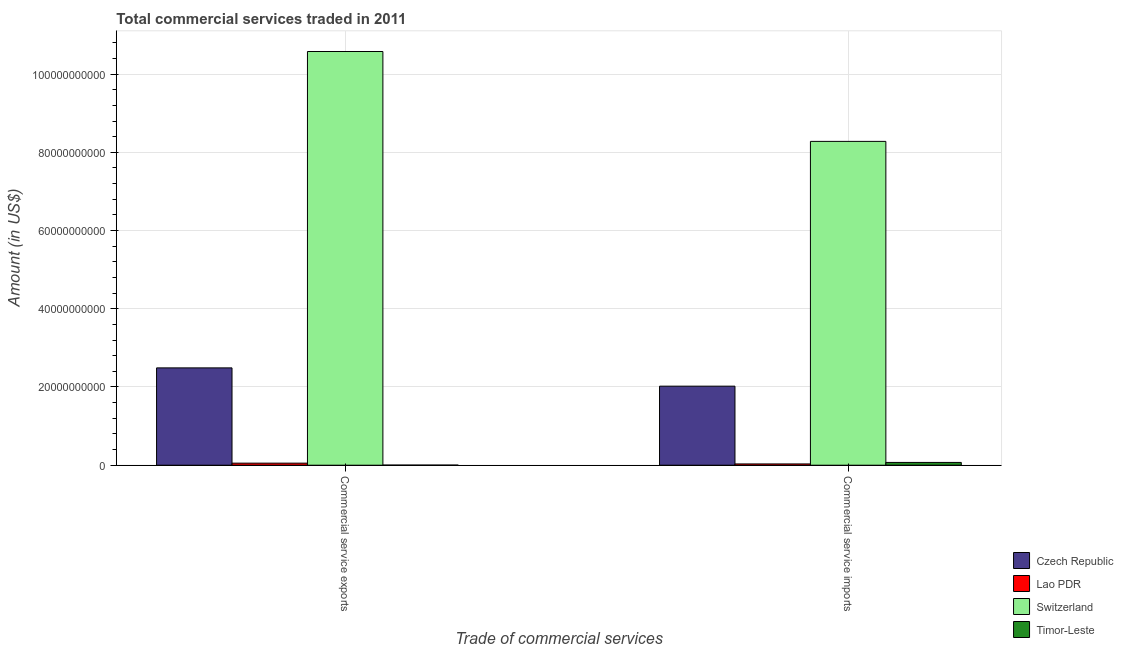How many different coloured bars are there?
Offer a terse response. 4. How many groups of bars are there?
Your answer should be compact. 2. Are the number of bars per tick equal to the number of legend labels?
Make the answer very short. Yes. How many bars are there on the 1st tick from the left?
Offer a terse response. 4. What is the label of the 2nd group of bars from the left?
Make the answer very short. Commercial service imports. What is the amount of commercial service imports in Lao PDR?
Provide a short and direct response. 3.25e+08. Across all countries, what is the maximum amount of commercial service exports?
Provide a short and direct response. 1.06e+11. Across all countries, what is the minimum amount of commercial service exports?
Provide a succinct answer. 2.55e+07. In which country was the amount of commercial service imports maximum?
Your response must be concise. Switzerland. In which country was the amount of commercial service exports minimum?
Keep it short and to the point. Timor-Leste. What is the total amount of commercial service exports in the graph?
Your answer should be very brief. 1.31e+11. What is the difference between the amount of commercial service exports in Czech Republic and that in Lao PDR?
Your answer should be compact. 2.44e+1. What is the difference between the amount of commercial service imports in Czech Republic and the amount of commercial service exports in Timor-Leste?
Give a very brief answer. 2.02e+1. What is the average amount of commercial service imports per country?
Ensure brevity in your answer.  2.60e+1. What is the difference between the amount of commercial service imports and amount of commercial service exports in Timor-Leste?
Make the answer very short. 6.84e+08. In how many countries, is the amount of commercial service exports greater than 36000000000 US$?
Give a very brief answer. 1. What is the ratio of the amount of commercial service imports in Lao PDR to that in Timor-Leste?
Keep it short and to the point. 0.46. Is the amount of commercial service imports in Switzerland less than that in Timor-Leste?
Your answer should be very brief. No. In how many countries, is the amount of commercial service exports greater than the average amount of commercial service exports taken over all countries?
Provide a short and direct response. 1. What does the 3rd bar from the left in Commercial service imports represents?
Your answer should be very brief. Switzerland. What does the 4th bar from the right in Commercial service imports represents?
Offer a very short reply. Czech Republic. Are all the bars in the graph horizontal?
Provide a short and direct response. No. Are the values on the major ticks of Y-axis written in scientific E-notation?
Offer a terse response. No. Does the graph contain any zero values?
Offer a terse response. No. Does the graph contain grids?
Offer a terse response. Yes. How many legend labels are there?
Give a very brief answer. 4. How are the legend labels stacked?
Ensure brevity in your answer.  Vertical. What is the title of the graph?
Provide a short and direct response. Total commercial services traded in 2011. What is the label or title of the X-axis?
Give a very brief answer. Trade of commercial services. What is the Amount (in US$) of Czech Republic in Commercial service exports?
Ensure brevity in your answer.  2.49e+1. What is the Amount (in US$) of Lao PDR in Commercial service exports?
Offer a very short reply. 5.26e+08. What is the Amount (in US$) in Switzerland in Commercial service exports?
Provide a succinct answer. 1.06e+11. What is the Amount (in US$) of Timor-Leste in Commercial service exports?
Ensure brevity in your answer.  2.55e+07. What is the Amount (in US$) in Czech Republic in Commercial service imports?
Provide a short and direct response. 2.02e+1. What is the Amount (in US$) of Lao PDR in Commercial service imports?
Provide a short and direct response. 3.25e+08. What is the Amount (in US$) in Switzerland in Commercial service imports?
Offer a terse response. 8.28e+1. What is the Amount (in US$) of Timor-Leste in Commercial service imports?
Make the answer very short. 7.10e+08. Across all Trade of commercial services, what is the maximum Amount (in US$) of Czech Republic?
Give a very brief answer. 2.49e+1. Across all Trade of commercial services, what is the maximum Amount (in US$) of Lao PDR?
Give a very brief answer. 5.26e+08. Across all Trade of commercial services, what is the maximum Amount (in US$) in Switzerland?
Offer a very short reply. 1.06e+11. Across all Trade of commercial services, what is the maximum Amount (in US$) in Timor-Leste?
Provide a short and direct response. 7.10e+08. Across all Trade of commercial services, what is the minimum Amount (in US$) in Czech Republic?
Offer a very short reply. 2.02e+1. Across all Trade of commercial services, what is the minimum Amount (in US$) of Lao PDR?
Your answer should be very brief. 3.25e+08. Across all Trade of commercial services, what is the minimum Amount (in US$) in Switzerland?
Offer a very short reply. 8.28e+1. Across all Trade of commercial services, what is the minimum Amount (in US$) of Timor-Leste?
Give a very brief answer. 2.55e+07. What is the total Amount (in US$) in Czech Republic in the graph?
Offer a very short reply. 4.51e+1. What is the total Amount (in US$) in Lao PDR in the graph?
Offer a terse response. 8.51e+08. What is the total Amount (in US$) in Switzerland in the graph?
Keep it short and to the point. 1.89e+11. What is the total Amount (in US$) in Timor-Leste in the graph?
Offer a terse response. 7.35e+08. What is the difference between the Amount (in US$) of Czech Republic in Commercial service exports and that in Commercial service imports?
Make the answer very short. 4.67e+09. What is the difference between the Amount (in US$) of Lao PDR in Commercial service exports and that in Commercial service imports?
Your response must be concise. 2.01e+08. What is the difference between the Amount (in US$) of Switzerland in Commercial service exports and that in Commercial service imports?
Make the answer very short. 2.30e+1. What is the difference between the Amount (in US$) in Timor-Leste in Commercial service exports and that in Commercial service imports?
Your answer should be compact. -6.84e+08. What is the difference between the Amount (in US$) of Czech Republic in Commercial service exports and the Amount (in US$) of Lao PDR in Commercial service imports?
Your answer should be compact. 2.46e+1. What is the difference between the Amount (in US$) in Czech Republic in Commercial service exports and the Amount (in US$) in Switzerland in Commercial service imports?
Ensure brevity in your answer.  -5.79e+1. What is the difference between the Amount (in US$) in Czech Republic in Commercial service exports and the Amount (in US$) in Timor-Leste in Commercial service imports?
Offer a very short reply. 2.42e+1. What is the difference between the Amount (in US$) in Lao PDR in Commercial service exports and the Amount (in US$) in Switzerland in Commercial service imports?
Keep it short and to the point. -8.23e+1. What is the difference between the Amount (in US$) of Lao PDR in Commercial service exports and the Amount (in US$) of Timor-Leste in Commercial service imports?
Give a very brief answer. -1.84e+08. What is the difference between the Amount (in US$) in Switzerland in Commercial service exports and the Amount (in US$) in Timor-Leste in Commercial service imports?
Your response must be concise. 1.05e+11. What is the average Amount (in US$) in Czech Republic per Trade of commercial services?
Give a very brief answer. 2.25e+1. What is the average Amount (in US$) of Lao PDR per Trade of commercial services?
Offer a terse response. 4.25e+08. What is the average Amount (in US$) in Switzerland per Trade of commercial services?
Ensure brevity in your answer.  9.43e+1. What is the average Amount (in US$) in Timor-Leste per Trade of commercial services?
Offer a very short reply. 3.68e+08. What is the difference between the Amount (in US$) in Czech Republic and Amount (in US$) in Lao PDR in Commercial service exports?
Provide a short and direct response. 2.44e+1. What is the difference between the Amount (in US$) in Czech Republic and Amount (in US$) in Switzerland in Commercial service exports?
Offer a very short reply. -8.09e+1. What is the difference between the Amount (in US$) in Czech Republic and Amount (in US$) in Timor-Leste in Commercial service exports?
Offer a terse response. 2.49e+1. What is the difference between the Amount (in US$) of Lao PDR and Amount (in US$) of Switzerland in Commercial service exports?
Provide a succinct answer. -1.05e+11. What is the difference between the Amount (in US$) of Lao PDR and Amount (in US$) of Timor-Leste in Commercial service exports?
Provide a short and direct response. 5.00e+08. What is the difference between the Amount (in US$) in Switzerland and Amount (in US$) in Timor-Leste in Commercial service exports?
Give a very brief answer. 1.06e+11. What is the difference between the Amount (in US$) in Czech Republic and Amount (in US$) in Lao PDR in Commercial service imports?
Your answer should be very brief. 1.99e+1. What is the difference between the Amount (in US$) of Czech Republic and Amount (in US$) of Switzerland in Commercial service imports?
Offer a terse response. -6.26e+1. What is the difference between the Amount (in US$) in Czech Republic and Amount (in US$) in Timor-Leste in Commercial service imports?
Make the answer very short. 1.95e+1. What is the difference between the Amount (in US$) of Lao PDR and Amount (in US$) of Switzerland in Commercial service imports?
Keep it short and to the point. -8.25e+1. What is the difference between the Amount (in US$) of Lao PDR and Amount (in US$) of Timor-Leste in Commercial service imports?
Offer a very short reply. -3.85e+08. What is the difference between the Amount (in US$) in Switzerland and Amount (in US$) in Timor-Leste in Commercial service imports?
Keep it short and to the point. 8.21e+1. What is the ratio of the Amount (in US$) of Czech Republic in Commercial service exports to that in Commercial service imports?
Your answer should be very brief. 1.23. What is the ratio of the Amount (in US$) in Lao PDR in Commercial service exports to that in Commercial service imports?
Your response must be concise. 1.62. What is the ratio of the Amount (in US$) of Switzerland in Commercial service exports to that in Commercial service imports?
Offer a terse response. 1.28. What is the ratio of the Amount (in US$) of Timor-Leste in Commercial service exports to that in Commercial service imports?
Keep it short and to the point. 0.04. What is the difference between the highest and the second highest Amount (in US$) of Czech Republic?
Make the answer very short. 4.67e+09. What is the difference between the highest and the second highest Amount (in US$) in Lao PDR?
Offer a very short reply. 2.01e+08. What is the difference between the highest and the second highest Amount (in US$) of Switzerland?
Offer a terse response. 2.30e+1. What is the difference between the highest and the second highest Amount (in US$) in Timor-Leste?
Provide a short and direct response. 6.84e+08. What is the difference between the highest and the lowest Amount (in US$) in Czech Republic?
Provide a succinct answer. 4.67e+09. What is the difference between the highest and the lowest Amount (in US$) in Lao PDR?
Make the answer very short. 2.01e+08. What is the difference between the highest and the lowest Amount (in US$) in Switzerland?
Your answer should be compact. 2.30e+1. What is the difference between the highest and the lowest Amount (in US$) of Timor-Leste?
Provide a short and direct response. 6.84e+08. 